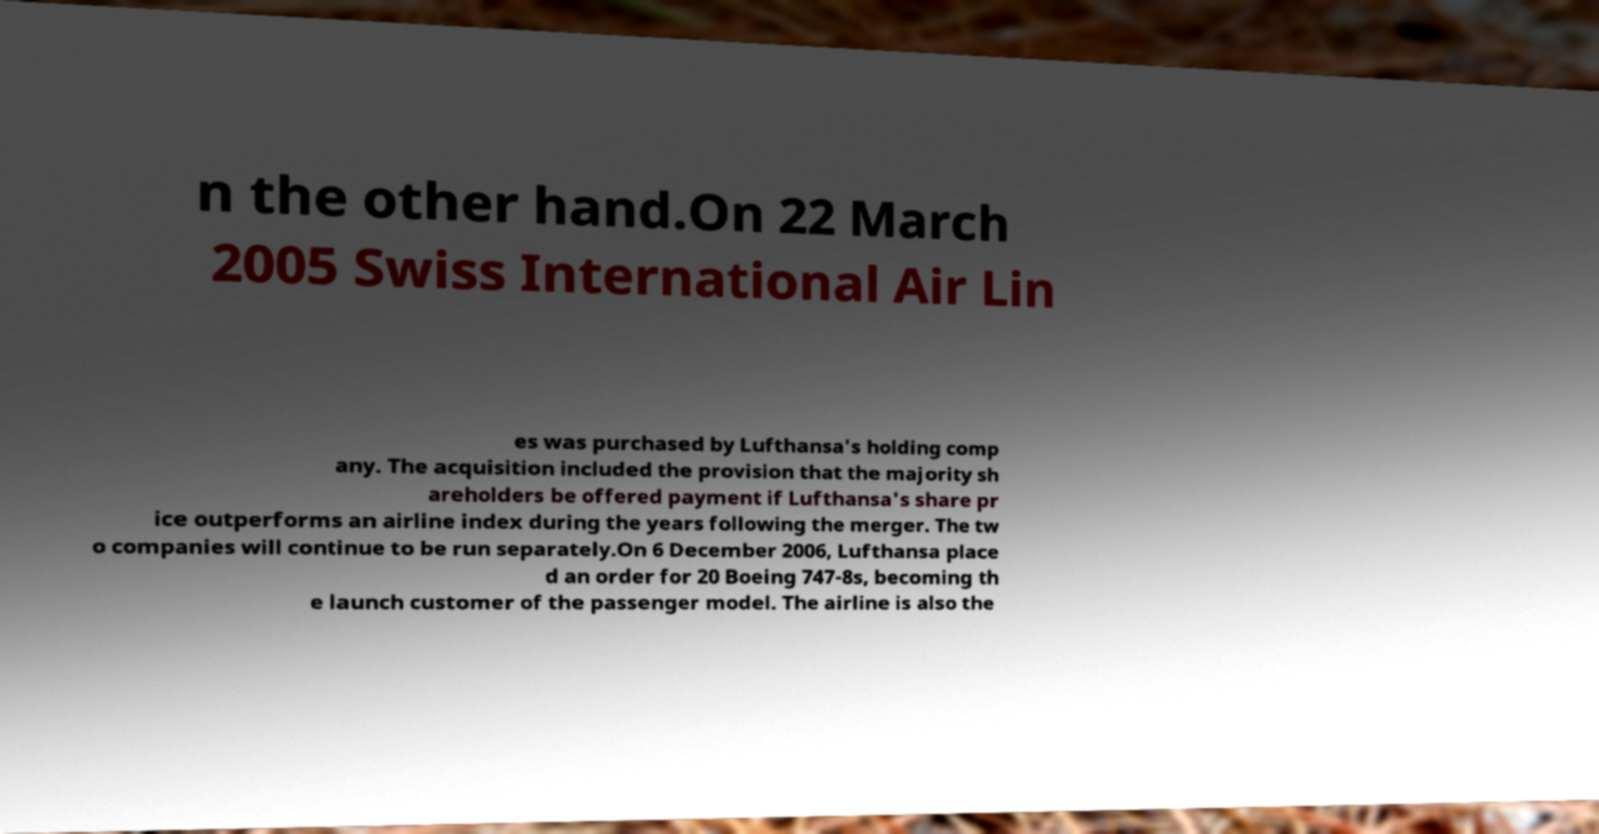What messages or text are displayed in this image? I need them in a readable, typed format. n the other hand.On 22 March 2005 Swiss International Air Lin es was purchased by Lufthansa's holding comp any. The acquisition included the provision that the majority sh areholders be offered payment if Lufthansa's share pr ice outperforms an airline index during the years following the merger. The tw o companies will continue to be run separately.On 6 December 2006, Lufthansa place d an order for 20 Boeing 747-8s, becoming th e launch customer of the passenger model. The airline is also the 